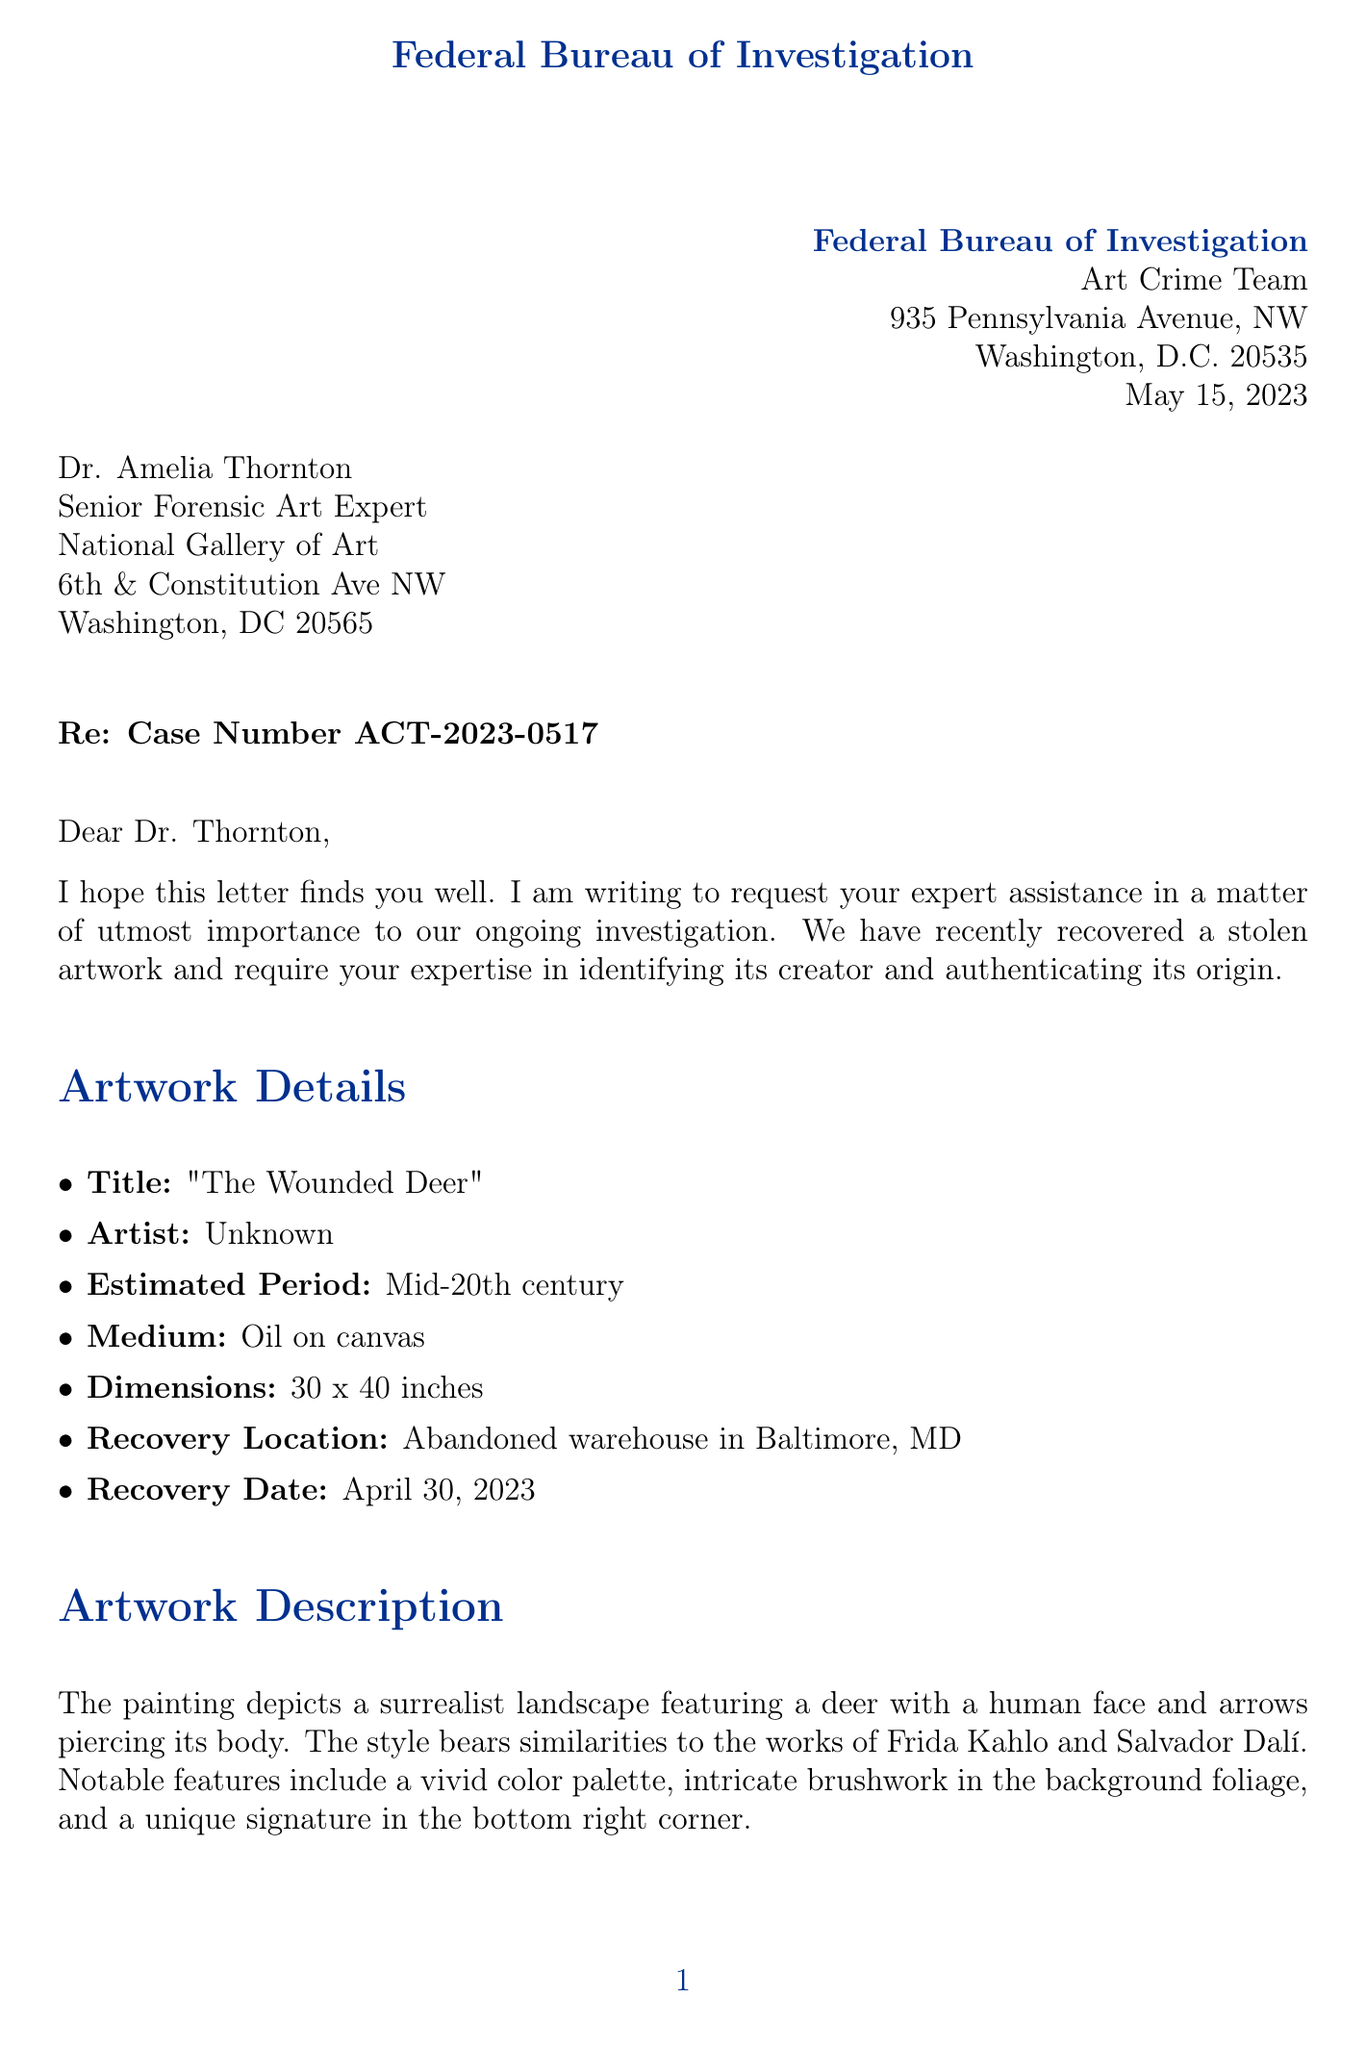What is the agency name? The agency name is provided at the top of the document as the sender, which is the Federal Bureau of Investigation.
Answer: Federal Bureau of Investigation What is the case number? The document includes a specific case number reference for tracking the investigation, which is indicated in the subject line.
Answer: ACT-2023-0517 When was the artwork recovered? The recovery date is stated in the case details section of the letter.
Answer: April 30, 2023 What is the estimated period of the artwork? The letter explicitly mentions the estimated period associated with the artwork.
Answer: Mid-20th century Who is the recipient of the letter? The recipient's name and title are clearly stated in the address section at the start of the letter.
Answer: Dr. Amelia Thornton Why might the artwork be linked to organized crime? The document outlines potential links to an international art theft ring as part of the relevant investigation details.
Answer: Potential links to an international art theft ring What specific type of analysis is requested? The letter lists requested areas of expertise, specifically mentioning a thorough analysis of the painting’s style, technique, and materials.
Answer: Conduct a thorough analysis of the painting's style, technique, and materials What is the response deadline for the request? The letter specifies a date by which a response is required.
Answer: June 15, 2023 What level of confidentiality is indicated in the document? The document declares the matter's confidentiality level explicitly.
Answer: Top Secret 